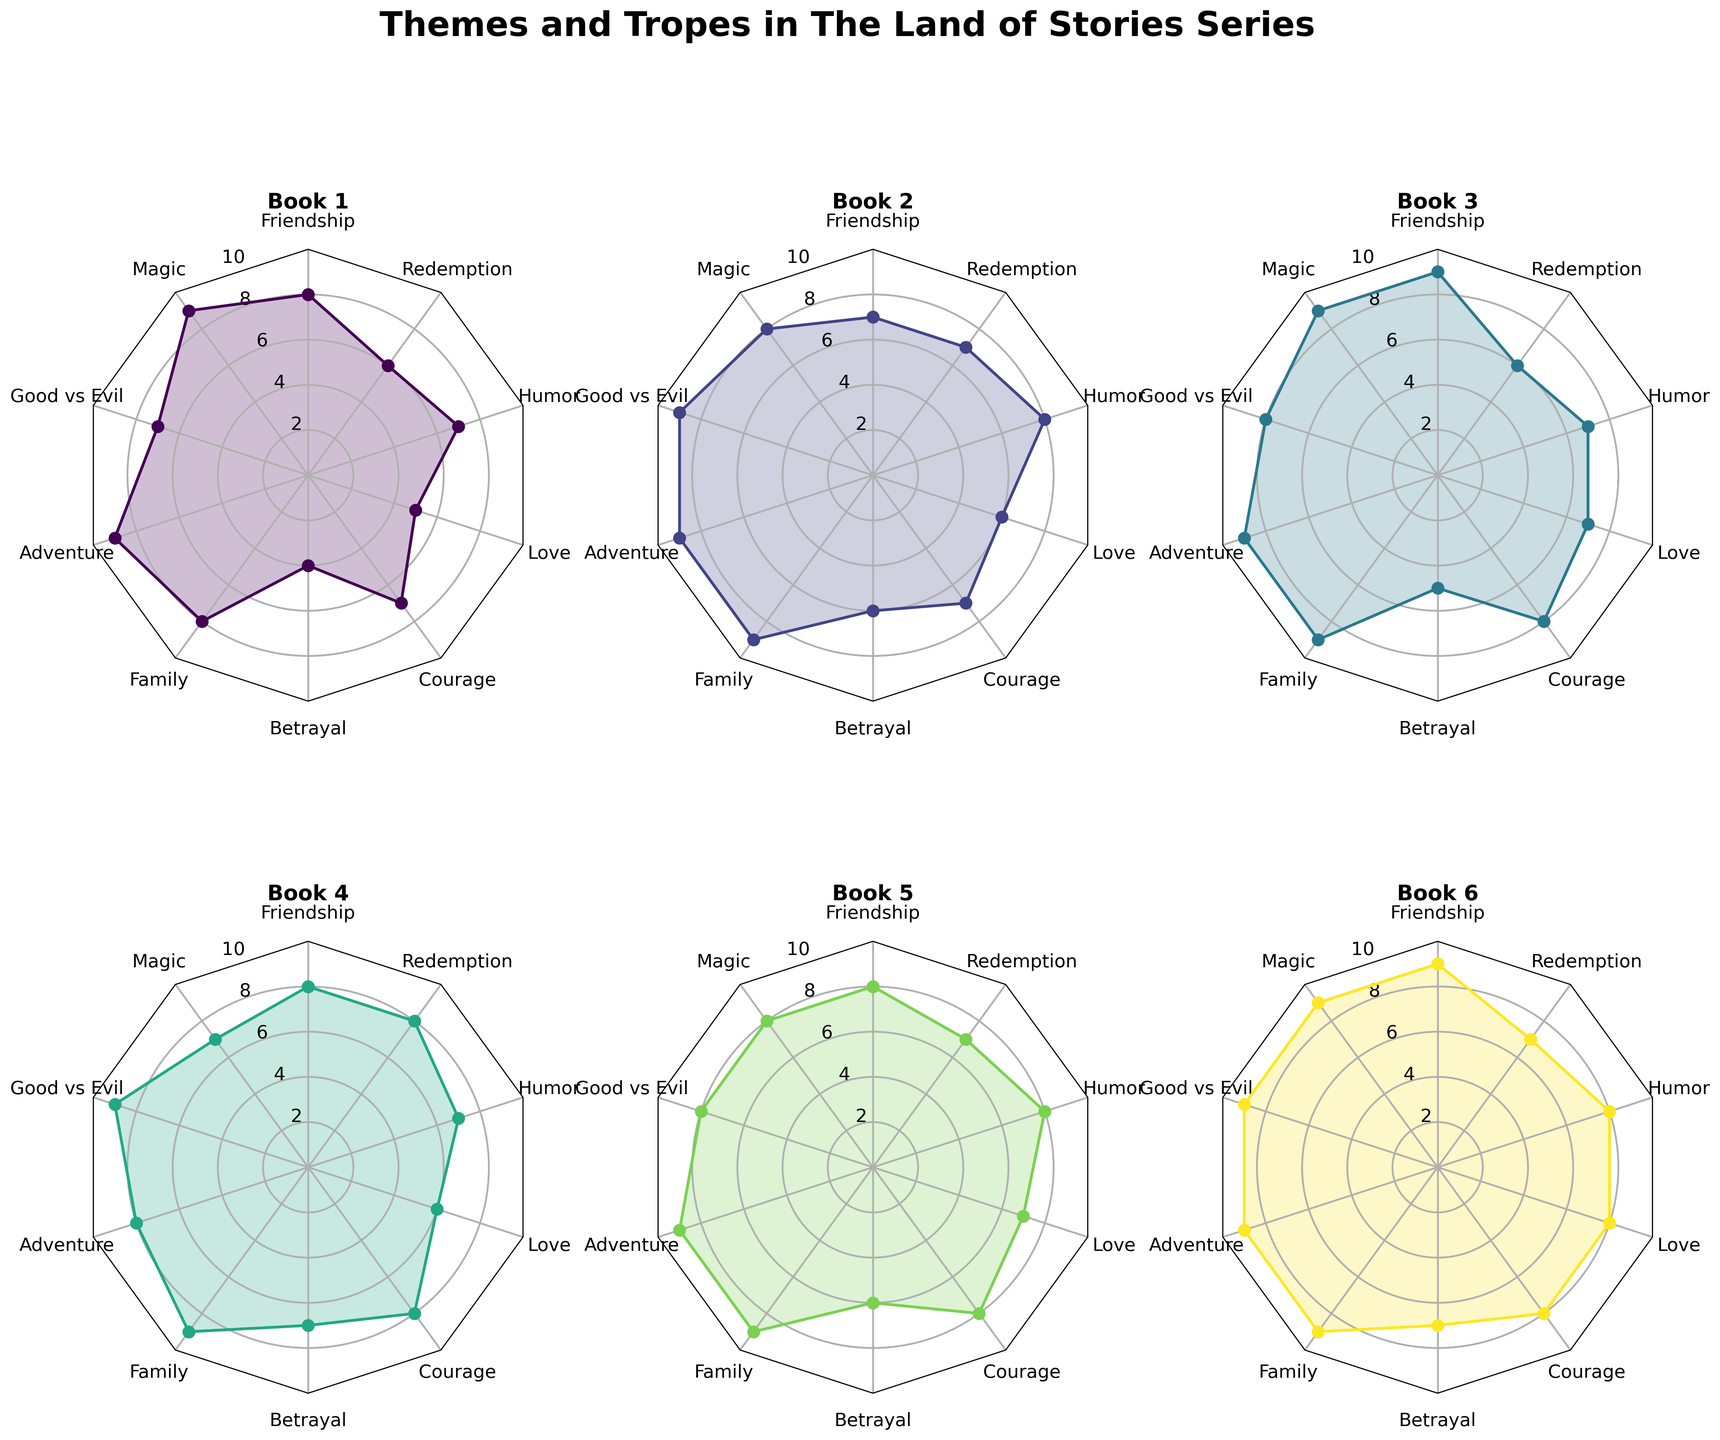Which book shows the highest frequency of the theme "Betrayal"? To determine this, look at the "Betrayal" values for all books in the radar charts. Book 4 and Book 6 have the highest frequency, both with a value of 7.
Answer: Book 4 and Book 6 Which theme has the least frequency in Book 1? Look at the values for all themes in Book 1. "Betrayal" has the least frequency with a value of 4.
Answer: Betrayal How does the frequency of the theme "Friendship" in Book 3 compare to that in Book 2? Compare the Friendship values for both Book 3 and Book 2. Book 3 has a higher frequency (9) compared to Book 2 (7).
Answer: Book 3 has a higher frequency What's the average frequency of the theme "Magic" across all books? Sum the frequencies of "Magic" in all books (9+8+9+7+8+9=50), then divide by the number of books (6). The average is 50/6, approximately 8.33.
Answer: 8.33 Which book has the most balanced frequencies across all themes and tropes? Examine the radar charts to see which book has the least variance among values. Book 5 appears balanced with most theme frequencies around 8-9.
Answer: Book 5 Which theme shows the most consistent frequency across all books? Check the theme values across all books for consistency. "Family" (Siblings as Key Characters) is consistently high with values of 8 and 9 across all books.
Answer: Family What is the highest frequency value of any theme in Book 4 and which theme does it correspond to? Identify the highest value in Book 4 and its corresponding theme. The highest value is 9, and it corresponds to the themes "Magic," "Good vs Evil," "Family," "Adventure," and "Courage."
Answer: 9 (Magic, Good vs Evil, Family, Adventure, and Courage) How does the frequency of themes in Book 1 compare to Book 6? Compare the radar charts of Book 1 and Book 6. Book 6 generally has higher or equal values for most themes compared to Book 1, especially higher in "Betrayal" and "Love."
Answer: Book 6 has generally higher or equal values 